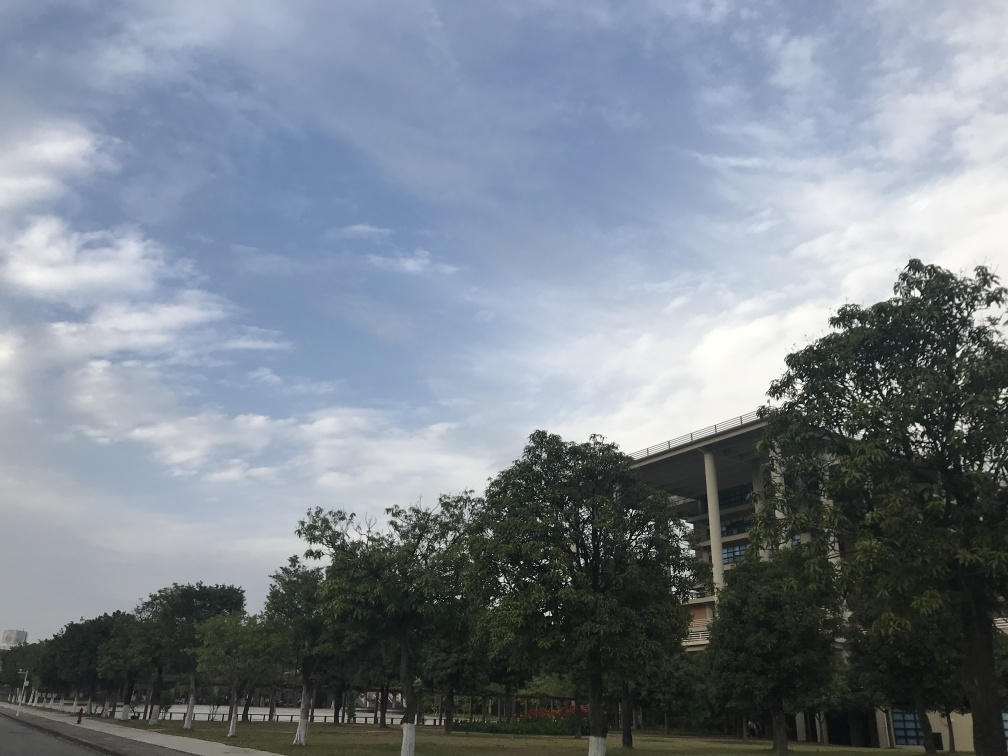Can you describe the weather conditions in the image? The weather appears to be fair, with a mix of blue skies and patchy clouds. It seems to be a pleasant day, likely with comfortable temperatures suitable for outdoor activities. 